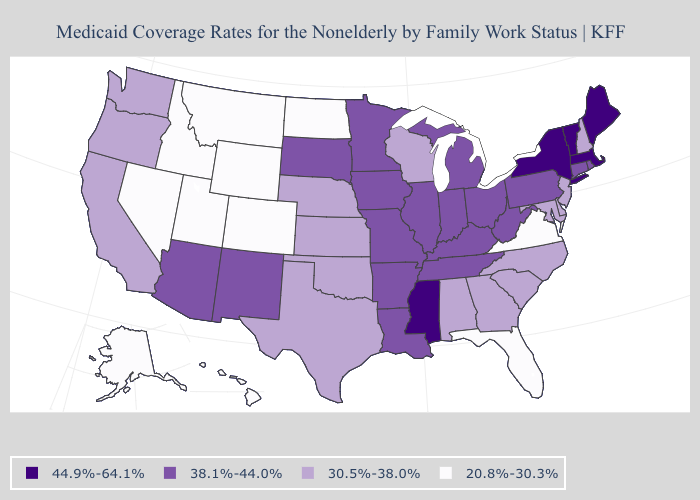What is the value of North Carolina?
Give a very brief answer. 30.5%-38.0%. What is the value of Iowa?
Be succinct. 38.1%-44.0%. What is the lowest value in states that border Rhode Island?
Concise answer only. 38.1%-44.0%. What is the value of California?
Answer briefly. 30.5%-38.0%. What is the highest value in states that border Kentucky?
Be succinct. 38.1%-44.0%. Name the states that have a value in the range 44.9%-64.1%?
Write a very short answer. Maine, Massachusetts, Mississippi, New York, Vermont. What is the value of Montana?
Keep it brief. 20.8%-30.3%. Name the states that have a value in the range 38.1%-44.0%?
Short answer required. Arizona, Arkansas, Connecticut, Illinois, Indiana, Iowa, Kentucky, Louisiana, Michigan, Minnesota, Missouri, New Mexico, Ohio, Pennsylvania, Rhode Island, South Dakota, Tennessee, West Virginia. Among the states that border Missouri , does Nebraska have the lowest value?
Answer briefly. Yes. What is the highest value in the USA?
Write a very short answer. 44.9%-64.1%. Among the states that border New York , does Massachusetts have the highest value?
Answer briefly. Yes. What is the value of New Mexico?
Concise answer only. 38.1%-44.0%. What is the highest value in states that border South Carolina?
Keep it brief. 30.5%-38.0%. Name the states that have a value in the range 30.5%-38.0%?
Quick response, please. Alabama, California, Delaware, Georgia, Kansas, Maryland, Nebraska, New Hampshire, New Jersey, North Carolina, Oklahoma, Oregon, South Carolina, Texas, Washington, Wisconsin. What is the value of Nebraska?
Give a very brief answer. 30.5%-38.0%. 